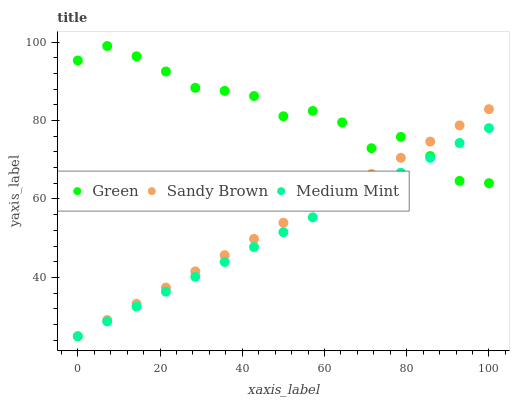Does Medium Mint have the minimum area under the curve?
Answer yes or no. Yes. Does Green have the maximum area under the curve?
Answer yes or no. Yes. Does Sandy Brown have the minimum area under the curve?
Answer yes or no. No. Does Sandy Brown have the maximum area under the curve?
Answer yes or no. No. Is Sandy Brown the smoothest?
Answer yes or no. Yes. Is Green the roughest?
Answer yes or no. Yes. Is Green the smoothest?
Answer yes or no. No. Is Sandy Brown the roughest?
Answer yes or no. No. Does Medium Mint have the lowest value?
Answer yes or no. Yes. Does Green have the lowest value?
Answer yes or no. No. Does Green have the highest value?
Answer yes or no. Yes. Does Sandy Brown have the highest value?
Answer yes or no. No. Does Sandy Brown intersect Green?
Answer yes or no. Yes. Is Sandy Brown less than Green?
Answer yes or no. No. Is Sandy Brown greater than Green?
Answer yes or no. No. 